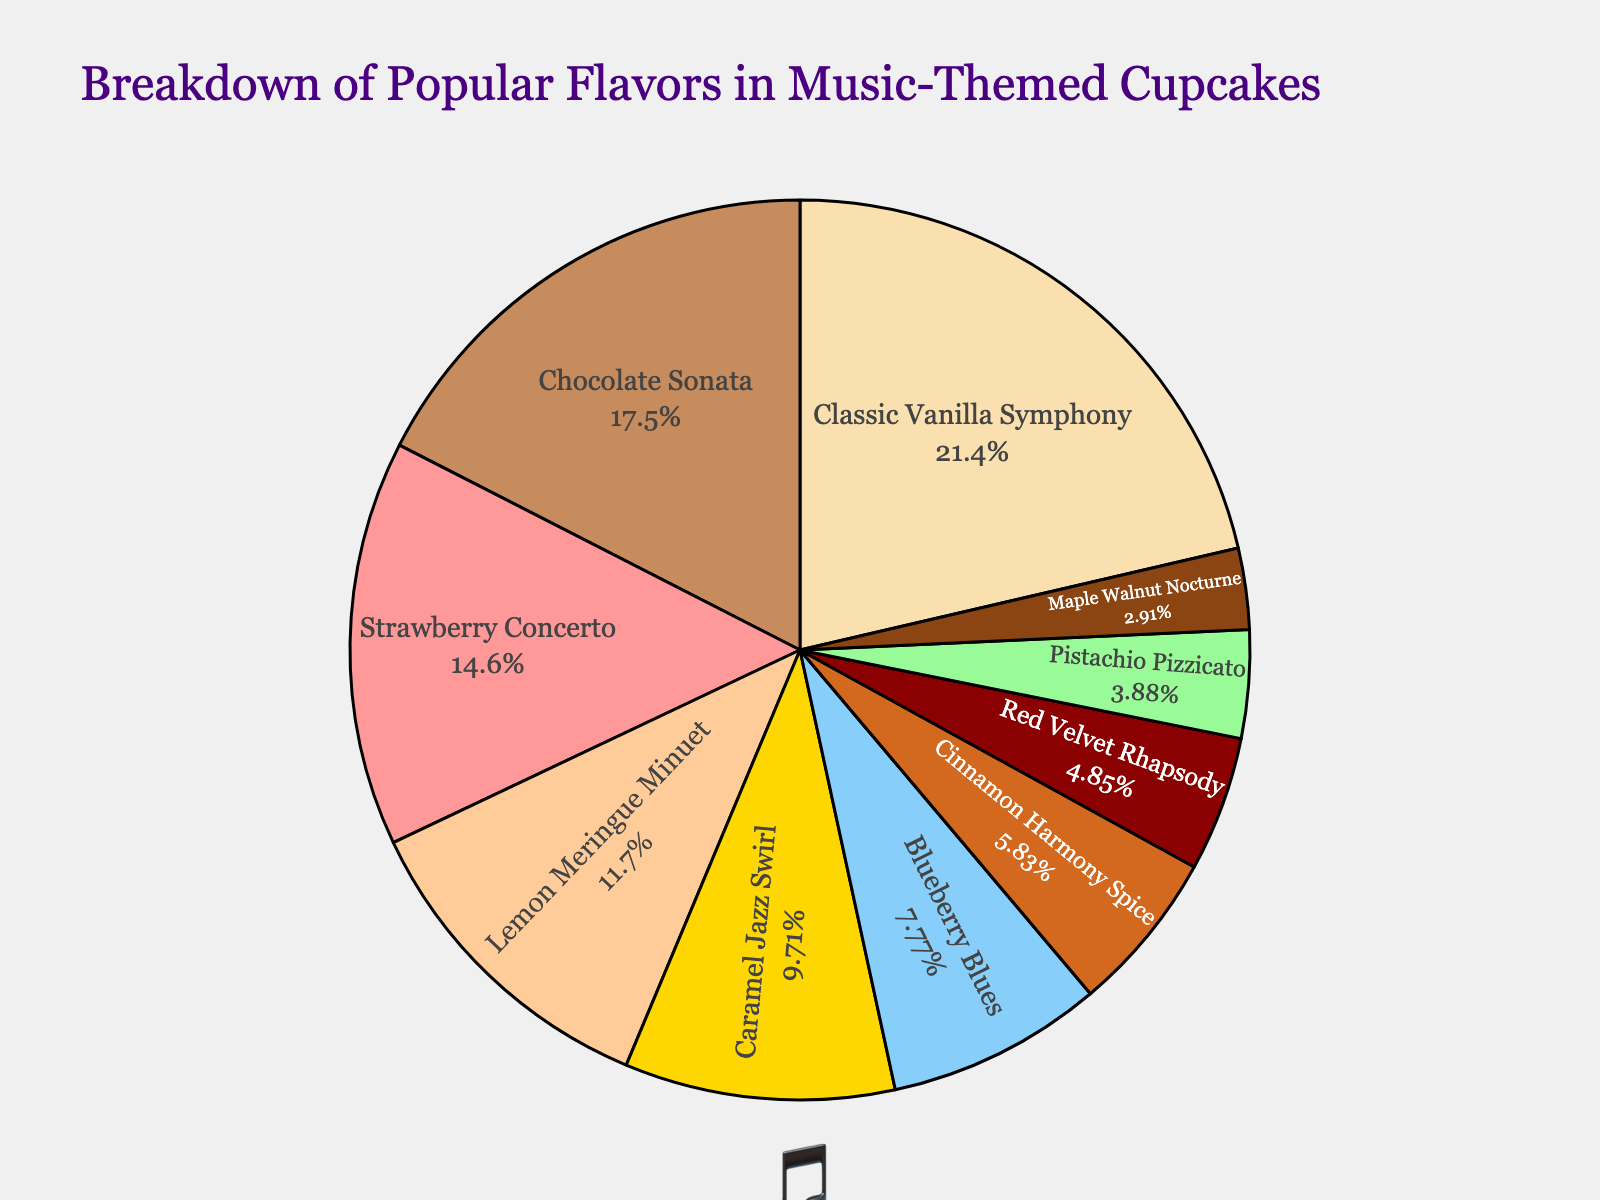what is the most popular flavor in the music-themed cupcakes? The largest segment in the pie chart represents the most popular flavor. The "Classic Vanilla Symphony" has the largest percentage.
Answer: Classic Vanilla Symphony what are the two least popular flavors? The smallest segments in the pie chart indicate the least popular flavors. The "Maple Walnut Nocturne" and "Pistachio Pizzicato" are the smallest slices.
Answer: Maple Walnut Nocturne, Pistachio Pizzicato how much larger is the percentage of "Classic Vanilla Symphony" compared to "Red Velvet Rhapsody"? "Classic Vanilla Symphony" is 22% and "Red Velvet Rhapsody" is 5%. Calculate the difference: 22% - 5% = 17%.
Answer: 17% what is the combined percentage of "Strawberry Concerto" and "Caramel Jazz Swirl"? "Strawberry Concerto" is 15% and "Caramel Jazz Swirl" is 10%. Summing these gives: 15% + 10% = 25%.
Answer: 25% which flavor is represented by the yellow slice? Yellow color in the pie chart corresponds to the flavor found in the legend and chart area. The "Classic Vanilla Symphony" slice is yellow.
Answer: Classic Vanilla Symphony what percentage of flavors fall below 10% each? Sum the percentages of flavors below 10%: "Blueberry Blues" 8% + "Cinnamon Harmony Spice" 6% + "Red Velvet Rhapsody" 5% + "Pistachio Pizzicato" 4% + "Maple Walnut Nocturne" 3% = 26%.
Answer: 26% how does the popularity of "Chocolate Sonata" compare to "Lemon Meringue Minuet"? "Chocolate Sonata" is 18% and "Lemon Meringue Minuet" is 12%. "Chocolate Sonata" is more popular.
Answer: Chocolate Sonata is more popular if "Classic Vanilla Symphony" and "Strawberry Concerto" combined, how would their percentage compare to the sum of "Chocolate Sonata" and "Caramel Jazz Swirl"? "Classic Vanilla Symphony" (22%) + "Strawberry Concerto" (15%) = 37%, "Chocolate Sonata" (18%) + "Caramel Jazz Swirl" (10%) = 28%. Compare 37% and 28%.
Answer: 37% is larger than 28% name three flavors that collectively make up over half the total percentage. Check combinations of flavors summing to over 50%. "Classic Vanilla Symphony" (22%) + "Chocolate Sonata" (18%) + "Strawberry Concerto" (15%) = 55%.
Answer: Classic Vanilla Symphony, Chocolate Sonata, Strawberry Concerto 